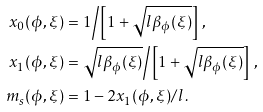<formula> <loc_0><loc_0><loc_500><loc_500>x _ { 0 } ( \phi , \xi ) & = 1 \Big / \left [ 1 + \sqrt { l \beta _ { \phi } ( \xi ) } \right ] \, , \\ x _ { 1 } ( \phi , \xi ) & = \sqrt { l \beta _ { \phi } ( \xi ) } \Big / \left [ 1 + \sqrt { l \beta _ { \phi } ( \xi ) } \right ] \, , \\ m _ { s } ( \phi , \xi ) & = 1 - 2 x _ { 1 } ( \phi , \xi ) / l \, .</formula> 